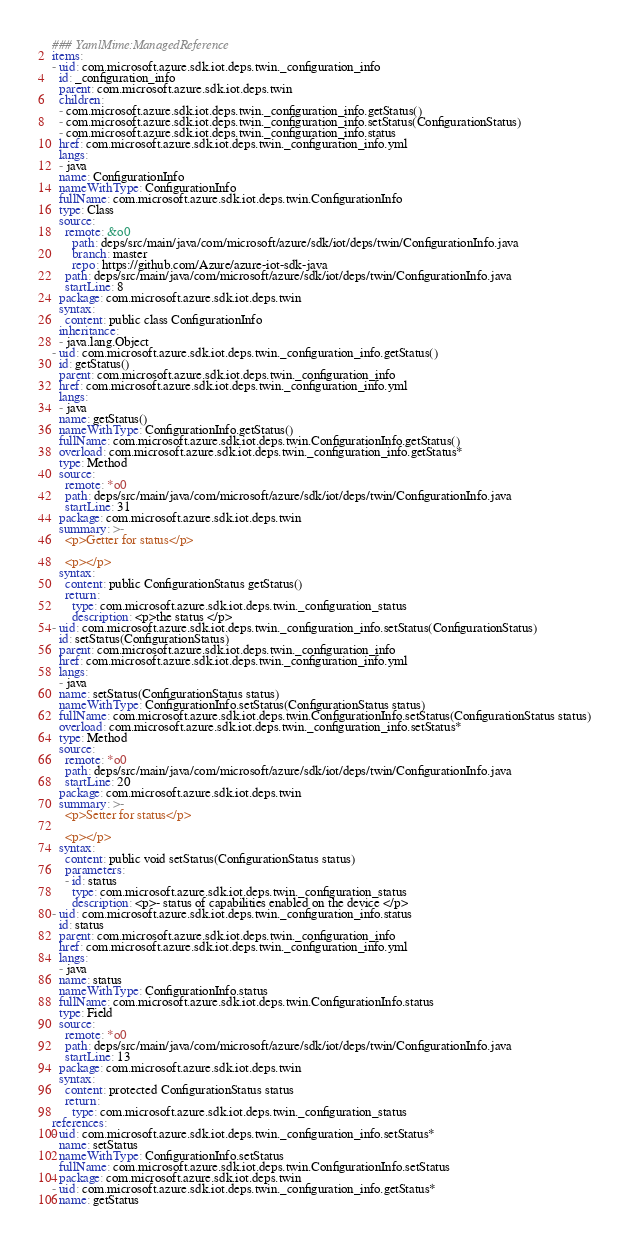Convert code to text. <code><loc_0><loc_0><loc_500><loc_500><_YAML_>### YamlMime:ManagedReference
items:
- uid: com.microsoft.azure.sdk.iot.deps.twin._configuration_info
  id: _configuration_info
  parent: com.microsoft.azure.sdk.iot.deps.twin
  children:
  - com.microsoft.azure.sdk.iot.deps.twin._configuration_info.getStatus()
  - com.microsoft.azure.sdk.iot.deps.twin._configuration_info.setStatus(ConfigurationStatus)
  - com.microsoft.azure.sdk.iot.deps.twin._configuration_info.status
  href: com.microsoft.azure.sdk.iot.deps.twin._configuration_info.yml
  langs:
  - java
  name: ConfigurationInfo
  nameWithType: ConfigurationInfo
  fullName: com.microsoft.azure.sdk.iot.deps.twin.ConfigurationInfo
  type: Class
  source:
    remote: &o0
      path: deps/src/main/java/com/microsoft/azure/sdk/iot/deps/twin/ConfigurationInfo.java
      branch: master
      repo: https://github.com/Azure/azure-iot-sdk-java
    path: deps/src/main/java/com/microsoft/azure/sdk/iot/deps/twin/ConfigurationInfo.java
    startLine: 8
  package: com.microsoft.azure.sdk.iot.deps.twin
  syntax:
    content: public class ConfigurationInfo
  inheritance:
  - java.lang.Object
- uid: com.microsoft.azure.sdk.iot.deps.twin._configuration_info.getStatus()
  id: getStatus()
  parent: com.microsoft.azure.sdk.iot.deps.twin._configuration_info
  href: com.microsoft.azure.sdk.iot.deps.twin._configuration_info.yml
  langs:
  - java
  name: getStatus()
  nameWithType: ConfigurationInfo.getStatus()
  fullName: com.microsoft.azure.sdk.iot.deps.twin.ConfigurationInfo.getStatus()
  overload: com.microsoft.azure.sdk.iot.deps.twin._configuration_info.getStatus*
  type: Method
  source:
    remote: *o0
    path: deps/src/main/java/com/microsoft/azure/sdk/iot/deps/twin/ConfigurationInfo.java
    startLine: 31
  package: com.microsoft.azure.sdk.iot.deps.twin
  summary: >-
    <p>Getter for status</p>

    <p></p>
  syntax:
    content: public ConfigurationStatus getStatus()
    return:
      type: com.microsoft.azure.sdk.iot.deps.twin._configuration_status
      description: <p>the status </p>
- uid: com.microsoft.azure.sdk.iot.deps.twin._configuration_info.setStatus(ConfigurationStatus)
  id: setStatus(ConfigurationStatus)
  parent: com.microsoft.azure.sdk.iot.deps.twin._configuration_info
  href: com.microsoft.azure.sdk.iot.deps.twin._configuration_info.yml
  langs:
  - java
  name: setStatus(ConfigurationStatus status)
  nameWithType: ConfigurationInfo.setStatus(ConfigurationStatus status)
  fullName: com.microsoft.azure.sdk.iot.deps.twin.ConfigurationInfo.setStatus(ConfigurationStatus status)
  overload: com.microsoft.azure.sdk.iot.deps.twin._configuration_info.setStatus*
  type: Method
  source:
    remote: *o0
    path: deps/src/main/java/com/microsoft/azure/sdk/iot/deps/twin/ConfigurationInfo.java
    startLine: 20
  package: com.microsoft.azure.sdk.iot.deps.twin
  summary: >-
    <p>Setter for status</p>

    <p></p>
  syntax:
    content: public void setStatus(ConfigurationStatus status)
    parameters:
    - id: status
      type: com.microsoft.azure.sdk.iot.deps.twin._configuration_status
      description: <p>- status of capabilities enabled on the device </p>
- uid: com.microsoft.azure.sdk.iot.deps.twin._configuration_info.status
  id: status
  parent: com.microsoft.azure.sdk.iot.deps.twin._configuration_info
  href: com.microsoft.azure.sdk.iot.deps.twin._configuration_info.yml
  langs:
  - java
  name: status
  nameWithType: ConfigurationInfo.status
  fullName: com.microsoft.azure.sdk.iot.deps.twin.ConfigurationInfo.status
  type: Field
  source:
    remote: *o0
    path: deps/src/main/java/com/microsoft/azure/sdk/iot/deps/twin/ConfigurationInfo.java
    startLine: 13
  package: com.microsoft.azure.sdk.iot.deps.twin
  syntax:
    content: protected ConfigurationStatus status
    return:
      type: com.microsoft.azure.sdk.iot.deps.twin._configuration_status
references:
- uid: com.microsoft.azure.sdk.iot.deps.twin._configuration_info.setStatus*
  name: setStatus
  nameWithType: ConfigurationInfo.setStatus
  fullName: com.microsoft.azure.sdk.iot.deps.twin.ConfigurationInfo.setStatus
  package: com.microsoft.azure.sdk.iot.deps.twin
- uid: com.microsoft.azure.sdk.iot.deps.twin._configuration_info.getStatus*
  name: getStatus</code> 